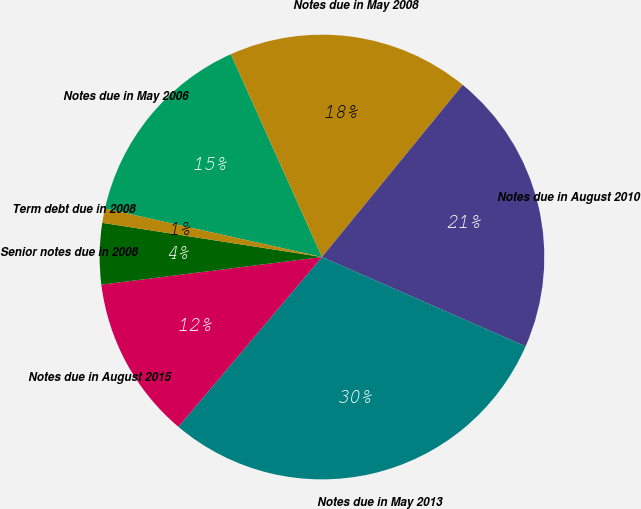<chart> <loc_0><loc_0><loc_500><loc_500><pie_chart><fcel>Notes due in May 2006<fcel>Notes due in May 2008<fcel>Notes due in August 2010<fcel>Notes due in May 2013<fcel>Notes due in August 2015<fcel>Senior notes due in 2008<fcel>Term debt due in 2008<nl><fcel>14.78%<fcel>17.63%<fcel>20.67%<fcel>29.59%<fcel>11.85%<fcel>4.44%<fcel>1.04%<nl></chart> 